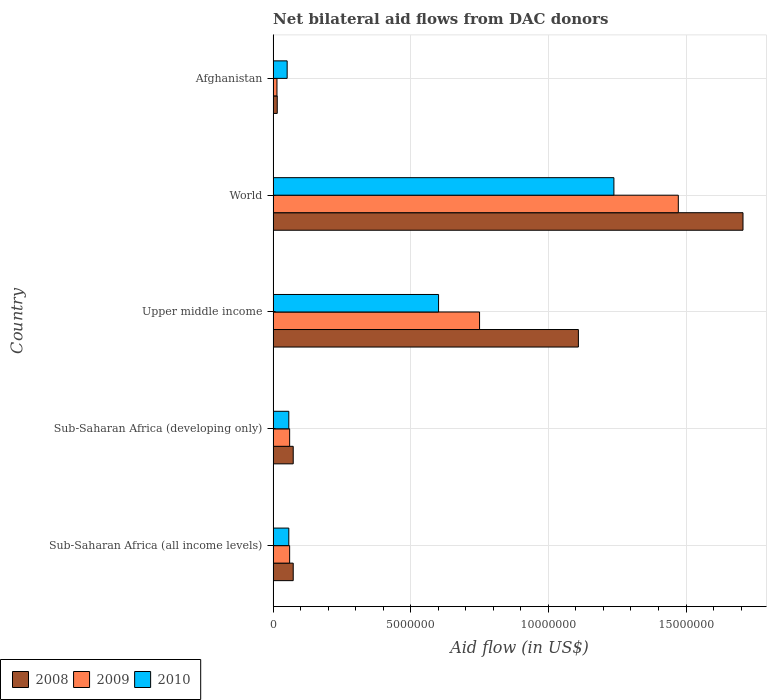How many different coloured bars are there?
Ensure brevity in your answer.  3. How many groups of bars are there?
Your response must be concise. 5. Are the number of bars per tick equal to the number of legend labels?
Offer a terse response. Yes. Are the number of bars on each tick of the Y-axis equal?
Your answer should be very brief. Yes. How many bars are there on the 1st tick from the top?
Provide a succinct answer. 3. How many bars are there on the 5th tick from the bottom?
Provide a short and direct response. 3. In how many cases, is the number of bars for a given country not equal to the number of legend labels?
Give a very brief answer. 0. What is the net bilateral aid flow in 2008 in Upper middle income?
Make the answer very short. 1.11e+07. Across all countries, what is the maximum net bilateral aid flow in 2009?
Provide a succinct answer. 1.47e+07. Across all countries, what is the minimum net bilateral aid flow in 2009?
Your answer should be very brief. 1.40e+05. In which country was the net bilateral aid flow in 2010 maximum?
Provide a succinct answer. World. In which country was the net bilateral aid flow in 2009 minimum?
Keep it short and to the point. Afghanistan. What is the total net bilateral aid flow in 2009 in the graph?
Give a very brief answer. 2.36e+07. What is the difference between the net bilateral aid flow in 2009 in Sub-Saharan Africa (all income levels) and that in World?
Offer a very short reply. -1.41e+07. What is the difference between the net bilateral aid flow in 2009 in Upper middle income and the net bilateral aid flow in 2010 in Afghanistan?
Your answer should be compact. 6.99e+06. What is the average net bilateral aid flow in 2008 per country?
Provide a short and direct response. 5.95e+06. What is the difference between the net bilateral aid flow in 2010 and net bilateral aid flow in 2008 in Sub-Saharan Africa (all income levels)?
Keep it short and to the point. -1.60e+05. In how many countries, is the net bilateral aid flow in 2008 greater than 15000000 US$?
Provide a short and direct response. 1. What is the ratio of the net bilateral aid flow in 2008 in Afghanistan to that in World?
Offer a very short reply. 0.01. What is the difference between the highest and the second highest net bilateral aid flow in 2009?
Ensure brevity in your answer.  7.22e+06. What is the difference between the highest and the lowest net bilateral aid flow in 2010?
Ensure brevity in your answer.  1.19e+07. Is the sum of the net bilateral aid flow in 2010 in Afghanistan and Sub-Saharan Africa (all income levels) greater than the maximum net bilateral aid flow in 2009 across all countries?
Offer a very short reply. No. What does the 3rd bar from the top in Sub-Saharan Africa (all income levels) represents?
Ensure brevity in your answer.  2008. What is the difference between two consecutive major ticks on the X-axis?
Keep it short and to the point. 5.00e+06. Does the graph contain grids?
Give a very brief answer. Yes. Where does the legend appear in the graph?
Provide a short and direct response. Bottom left. How are the legend labels stacked?
Offer a terse response. Horizontal. What is the title of the graph?
Your answer should be very brief. Net bilateral aid flows from DAC donors. What is the label or title of the X-axis?
Offer a very short reply. Aid flow (in US$). What is the label or title of the Y-axis?
Provide a short and direct response. Country. What is the Aid flow (in US$) in 2008 in Sub-Saharan Africa (all income levels)?
Provide a succinct answer. 7.30e+05. What is the Aid flow (in US$) of 2009 in Sub-Saharan Africa (all income levels)?
Your answer should be very brief. 6.00e+05. What is the Aid flow (in US$) of 2010 in Sub-Saharan Africa (all income levels)?
Give a very brief answer. 5.70e+05. What is the Aid flow (in US$) in 2008 in Sub-Saharan Africa (developing only)?
Your answer should be compact. 7.30e+05. What is the Aid flow (in US$) in 2009 in Sub-Saharan Africa (developing only)?
Offer a terse response. 6.00e+05. What is the Aid flow (in US$) in 2010 in Sub-Saharan Africa (developing only)?
Keep it short and to the point. 5.70e+05. What is the Aid flow (in US$) in 2008 in Upper middle income?
Give a very brief answer. 1.11e+07. What is the Aid flow (in US$) in 2009 in Upper middle income?
Your response must be concise. 7.50e+06. What is the Aid flow (in US$) in 2010 in Upper middle income?
Your response must be concise. 6.01e+06. What is the Aid flow (in US$) of 2008 in World?
Offer a very short reply. 1.71e+07. What is the Aid flow (in US$) in 2009 in World?
Ensure brevity in your answer.  1.47e+07. What is the Aid flow (in US$) of 2010 in World?
Keep it short and to the point. 1.24e+07. What is the Aid flow (in US$) in 2010 in Afghanistan?
Your response must be concise. 5.10e+05. Across all countries, what is the maximum Aid flow (in US$) of 2008?
Your answer should be compact. 1.71e+07. Across all countries, what is the maximum Aid flow (in US$) in 2009?
Offer a terse response. 1.47e+07. Across all countries, what is the maximum Aid flow (in US$) of 2010?
Provide a short and direct response. 1.24e+07. Across all countries, what is the minimum Aid flow (in US$) in 2009?
Keep it short and to the point. 1.40e+05. Across all countries, what is the minimum Aid flow (in US$) of 2010?
Provide a short and direct response. 5.10e+05. What is the total Aid flow (in US$) of 2008 in the graph?
Give a very brief answer. 2.98e+07. What is the total Aid flow (in US$) in 2009 in the graph?
Give a very brief answer. 2.36e+07. What is the total Aid flow (in US$) in 2010 in the graph?
Keep it short and to the point. 2.00e+07. What is the difference between the Aid flow (in US$) in 2009 in Sub-Saharan Africa (all income levels) and that in Sub-Saharan Africa (developing only)?
Provide a succinct answer. 0. What is the difference between the Aid flow (in US$) in 2008 in Sub-Saharan Africa (all income levels) and that in Upper middle income?
Offer a very short reply. -1.04e+07. What is the difference between the Aid flow (in US$) in 2009 in Sub-Saharan Africa (all income levels) and that in Upper middle income?
Ensure brevity in your answer.  -6.90e+06. What is the difference between the Aid flow (in US$) of 2010 in Sub-Saharan Africa (all income levels) and that in Upper middle income?
Your answer should be very brief. -5.44e+06. What is the difference between the Aid flow (in US$) of 2008 in Sub-Saharan Africa (all income levels) and that in World?
Keep it short and to the point. -1.63e+07. What is the difference between the Aid flow (in US$) of 2009 in Sub-Saharan Africa (all income levels) and that in World?
Provide a short and direct response. -1.41e+07. What is the difference between the Aid flow (in US$) of 2010 in Sub-Saharan Africa (all income levels) and that in World?
Your answer should be compact. -1.18e+07. What is the difference between the Aid flow (in US$) in 2008 in Sub-Saharan Africa (all income levels) and that in Afghanistan?
Provide a succinct answer. 5.80e+05. What is the difference between the Aid flow (in US$) of 2009 in Sub-Saharan Africa (all income levels) and that in Afghanistan?
Provide a succinct answer. 4.60e+05. What is the difference between the Aid flow (in US$) in 2010 in Sub-Saharan Africa (all income levels) and that in Afghanistan?
Ensure brevity in your answer.  6.00e+04. What is the difference between the Aid flow (in US$) of 2008 in Sub-Saharan Africa (developing only) and that in Upper middle income?
Keep it short and to the point. -1.04e+07. What is the difference between the Aid flow (in US$) of 2009 in Sub-Saharan Africa (developing only) and that in Upper middle income?
Ensure brevity in your answer.  -6.90e+06. What is the difference between the Aid flow (in US$) of 2010 in Sub-Saharan Africa (developing only) and that in Upper middle income?
Your response must be concise. -5.44e+06. What is the difference between the Aid flow (in US$) in 2008 in Sub-Saharan Africa (developing only) and that in World?
Your answer should be compact. -1.63e+07. What is the difference between the Aid flow (in US$) in 2009 in Sub-Saharan Africa (developing only) and that in World?
Offer a very short reply. -1.41e+07. What is the difference between the Aid flow (in US$) of 2010 in Sub-Saharan Africa (developing only) and that in World?
Your answer should be very brief. -1.18e+07. What is the difference between the Aid flow (in US$) of 2008 in Sub-Saharan Africa (developing only) and that in Afghanistan?
Make the answer very short. 5.80e+05. What is the difference between the Aid flow (in US$) in 2009 in Sub-Saharan Africa (developing only) and that in Afghanistan?
Your response must be concise. 4.60e+05. What is the difference between the Aid flow (in US$) of 2010 in Sub-Saharan Africa (developing only) and that in Afghanistan?
Your answer should be very brief. 6.00e+04. What is the difference between the Aid flow (in US$) in 2008 in Upper middle income and that in World?
Offer a terse response. -5.98e+06. What is the difference between the Aid flow (in US$) of 2009 in Upper middle income and that in World?
Offer a terse response. -7.22e+06. What is the difference between the Aid flow (in US$) of 2010 in Upper middle income and that in World?
Provide a short and direct response. -6.37e+06. What is the difference between the Aid flow (in US$) of 2008 in Upper middle income and that in Afghanistan?
Your answer should be very brief. 1.09e+07. What is the difference between the Aid flow (in US$) of 2009 in Upper middle income and that in Afghanistan?
Ensure brevity in your answer.  7.36e+06. What is the difference between the Aid flow (in US$) in 2010 in Upper middle income and that in Afghanistan?
Your answer should be compact. 5.50e+06. What is the difference between the Aid flow (in US$) of 2008 in World and that in Afghanistan?
Provide a succinct answer. 1.69e+07. What is the difference between the Aid flow (in US$) of 2009 in World and that in Afghanistan?
Give a very brief answer. 1.46e+07. What is the difference between the Aid flow (in US$) of 2010 in World and that in Afghanistan?
Give a very brief answer. 1.19e+07. What is the difference between the Aid flow (in US$) in 2008 in Sub-Saharan Africa (all income levels) and the Aid flow (in US$) in 2009 in Sub-Saharan Africa (developing only)?
Your answer should be compact. 1.30e+05. What is the difference between the Aid flow (in US$) in 2008 in Sub-Saharan Africa (all income levels) and the Aid flow (in US$) in 2009 in Upper middle income?
Make the answer very short. -6.77e+06. What is the difference between the Aid flow (in US$) of 2008 in Sub-Saharan Africa (all income levels) and the Aid flow (in US$) of 2010 in Upper middle income?
Your response must be concise. -5.28e+06. What is the difference between the Aid flow (in US$) in 2009 in Sub-Saharan Africa (all income levels) and the Aid flow (in US$) in 2010 in Upper middle income?
Your response must be concise. -5.41e+06. What is the difference between the Aid flow (in US$) of 2008 in Sub-Saharan Africa (all income levels) and the Aid flow (in US$) of 2009 in World?
Provide a succinct answer. -1.40e+07. What is the difference between the Aid flow (in US$) of 2008 in Sub-Saharan Africa (all income levels) and the Aid flow (in US$) of 2010 in World?
Keep it short and to the point. -1.16e+07. What is the difference between the Aid flow (in US$) of 2009 in Sub-Saharan Africa (all income levels) and the Aid flow (in US$) of 2010 in World?
Offer a terse response. -1.18e+07. What is the difference between the Aid flow (in US$) in 2008 in Sub-Saharan Africa (all income levels) and the Aid flow (in US$) in 2009 in Afghanistan?
Your answer should be very brief. 5.90e+05. What is the difference between the Aid flow (in US$) in 2008 in Sub-Saharan Africa (all income levels) and the Aid flow (in US$) in 2010 in Afghanistan?
Make the answer very short. 2.20e+05. What is the difference between the Aid flow (in US$) in 2008 in Sub-Saharan Africa (developing only) and the Aid flow (in US$) in 2009 in Upper middle income?
Your response must be concise. -6.77e+06. What is the difference between the Aid flow (in US$) of 2008 in Sub-Saharan Africa (developing only) and the Aid flow (in US$) of 2010 in Upper middle income?
Give a very brief answer. -5.28e+06. What is the difference between the Aid flow (in US$) of 2009 in Sub-Saharan Africa (developing only) and the Aid flow (in US$) of 2010 in Upper middle income?
Offer a very short reply. -5.41e+06. What is the difference between the Aid flow (in US$) of 2008 in Sub-Saharan Africa (developing only) and the Aid flow (in US$) of 2009 in World?
Make the answer very short. -1.40e+07. What is the difference between the Aid flow (in US$) of 2008 in Sub-Saharan Africa (developing only) and the Aid flow (in US$) of 2010 in World?
Your response must be concise. -1.16e+07. What is the difference between the Aid flow (in US$) in 2009 in Sub-Saharan Africa (developing only) and the Aid flow (in US$) in 2010 in World?
Your answer should be compact. -1.18e+07. What is the difference between the Aid flow (in US$) of 2008 in Sub-Saharan Africa (developing only) and the Aid flow (in US$) of 2009 in Afghanistan?
Offer a very short reply. 5.90e+05. What is the difference between the Aid flow (in US$) of 2008 in Upper middle income and the Aid flow (in US$) of 2009 in World?
Offer a terse response. -3.63e+06. What is the difference between the Aid flow (in US$) of 2008 in Upper middle income and the Aid flow (in US$) of 2010 in World?
Your response must be concise. -1.29e+06. What is the difference between the Aid flow (in US$) of 2009 in Upper middle income and the Aid flow (in US$) of 2010 in World?
Keep it short and to the point. -4.88e+06. What is the difference between the Aid flow (in US$) of 2008 in Upper middle income and the Aid flow (in US$) of 2009 in Afghanistan?
Give a very brief answer. 1.10e+07. What is the difference between the Aid flow (in US$) of 2008 in Upper middle income and the Aid flow (in US$) of 2010 in Afghanistan?
Offer a terse response. 1.06e+07. What is the difference between the Aid flow (in US$) of 2009 in Upper middle income and the Aid flow (in US$) of 2010 in Afghanistan?
Your answer should be very brief. 6.99e+06. What is the difference between the Aid flow (in US$) in 2008 in World and the Aid flow (in US$) in 2009 in Afghanistan?
Your response must be concise. 1.69e+07. What is the difference between the Aid flow (in US$) of 2008 in World and the Aid flow (in US$) of 2010 in Afghanistan?
Provide a short and direct response. 1.66e+07. What is the difference between the Aid flow (in US$) of 2009 in World and the Aid flow (in US$) of 2010 in Afghanistan?
Give a very brief answer. 1.42e+07. What is the average Aid flow (in US$) in 2008 per country?
Give a very brief answer. 5.95e+06. What is the average Aid flow (in US$) of 2009 per country?
Ensure brevity in your answer.  4.71e+06. What is the average Aid flow (in US$) of 2010 per country?
Keep it short and to the point. 4.01e+06. What is the difference between the Aid flow (in US$) in 2009 and Aid flow (in US$) in 2010 in Sub-Saharan Africa (all income levels)?
Offer a terse response. 3.00e+04. What is the difference between the Aid flow (in US$) of 2008 and Aid flow (in US$) of 2009 in Sub-Saharan Africa (developing only)?
Ensure brevity in your answer.  1.30e+05. What is the difference between the Aid flow (in US$) of 2008 and Aid flow (in US$) of 2010 in Sub-Saharan Africa (developing only)?
Your answer should be compact. 1.60e+05. What is the difference between the Aid flow (in US$) of 2009 and Aid flow (in US$) of 2010 in Sub-Saharan Africa (developing only)?
Offer a very short reply. 3.00e+04. What is the difference between the Aid flow (in US$) in 2008 and Aid flow (in US$) in 2009 in Upper middle income?
Give a very brief answer. 3.59e+06. What is the difference between the Aid flow (in US$) in 2008 and Aid flow (in US$) in 2010 in Upper middle income?
Your answer should be compact. 5.08e+06. What is the difference between the Aid flow (in US$) of 2009 and Aid flow (in US$) of 2010 in Upper middle income?
Make the answer very short. 1.49e+06. What is the difference between the Aid flow (in US$) of 2008 and Aid flow (in US$) of 2009 in World?
Give a very brief answer. 2.35e+06. What is the difference between the Aid flow (in US$) in 2008 and Aid flow (in US$) in 2010 in World?
Give a very brief answer. 4.69e+06. What is the difference between the Aid flow (in US$) of 2009 and Aid flow (in US$) of 2010 in World?
Your answer should be very brief. 2.34e+06. What is the difference between the Aid flow (in US$) in 2008 and Aid flow (in US$) in 2009 in Afghanistan?
Offer a very short reply. 10000. What is the difference between the Aid flow (in US$) in 2008 and Aid flow (in US$) in 2010 in Afghanistan?
Offer a terse response. -3.60e+05. What is the difference between the Aid flow (in US$) of 2009 and Aid flow (in US$) of 2010 in Afghanistan?
Your answer should be very brief. -3.70e+05. What is the ratio of the Aid flow (in US$) in 2008 in Sub-Saharan Africa (all income levels) to that in Sub-Saharan Africa (developing only)?
Offer a very short reply. 1. What is the ratio of the Aid flow (in US$) in 2008 in Sub-Saharan Africa (all income levels) to that in Upper middle income?
Keep it short and to the point. 0.07. What is the ratio of the Aid flow (in US$) of 2010 in Sub-Saharan Africa (all income levels) to that in Upper middle income?
Make the answer very short. 0.09. What is the ratio of the Aid flow (in US$) in 2008 in Sub-Saharan Africa (all income levels) to that in World?
Offer a very short reply. 0.04. What is the ratio of the Aid flow (in US$) in 2009 in Sub-Saharan Africa (all income levels) to that in World?
Give a very brief answer. 0.04. What is the ratio of the Aid flow (in US$) of 2010 in Sub-Saharan Africa (all income levels) to that in World?
Provide a succinct answer. 0.05. What is the ratio of the Aid flow (in US$) in 2008 in Sub-Saharan Africa (all income levels) to that in Afghanistan?
Make the answer very short. 4.87. What is the ratio of the Aid flow (in US$) in 2009 in Sub-Saharan Africa (all income levels) to that in Afghanistan?
Your answer should be compact. 4.29. What is the ratio of the Aid flow (in US$) in 2010 in Sub-Saharan Africa (all income levels) to that in Afghanistan?
Give a very brief answer. 1.12. What is the ratio of the Aid flow (in US$) in 2008 in Sub-Saharan Africa (developing only) to that in Upper middle income?
Keep it short and to the point. 0.07. What is the ratio of the Aid flow (in US$) in 2009 in Sub-Saharan Africa (developing only) to that in Upper middle income?
Provide a short and direct response. 0.08. What is the ratio of the Aid flow (in US$) of 2010 in Sub-Saharan Africa (developing only) to that in Upper middle income?
Your answer should be compact. 0.09. What is the ratio of the Aid flow (in US$) in 2008 in Sub-Saharan Africa (developing only) to that in World?
Keep it short and to the point. 0.04. What is the ratio of the Aid flow (in US$) in 2009 in Sub-Saharan Africa (developing only) to that in World?
Keep it short and to the point. 0.04. What is the ratio of the Aid flow (in US$) in 2010 in Sub-Saharan Africa (developing only) to that in World?
Provide a short and direct response. 0.05. What is the ratio of the Aid flow (in US$) of 2008 in Sub-Saharan Africa (developing only) to that in Afghanistan?
Your answer should be very brief. 4.87. What is the ratio of the Aid flow (in US$) in 2009 in Sub-Saharan Africa (developing only) to that in Afghanistan?
Make the answer very short. 4.29. What is the ratio of the Aid flow (in US$) in 2010 in Sub-Saharan Africa (developing only) to that in Afghanistan?
Your response must be concise. 1.12. What is the ratio of the Aid flow (in US$) of 2008 in Upper middle income to that in World?
Keep it short and to the point. 0.65. What is the ratio of the Aid flow (in US$) of 2009 in Upper middle income to that in World?
Your answer should be very brief. 0.51. What is the ratio of the Aid flow (in US$) of 2010 in Upper middle income to that in World?
Provide a succinct answer. 0.49. What is the ratio of the Aid flow (in US$) in 2008 in Upper middle income to that in Afghanistan?
Keep it short and to the point. 73.93. What is the ratio of the Aid flow (in US$) in 2009 in Upper middle income to that in Afghanistan?
Offer a very short reply. 53.57. What is the ratio of the Aid flow (in US$) in 2010 in Upper middle income to that in Afghanistan?
Your answer should be compact. 11.78. What is the ratio of the Aid flow (in US$) of 2008 in World to that in Afghanistan?
Your answer should be very brief. 113.8. What is the ratio of the Aid flow (in US$) of 2009 in World to that in Afghanistan?
Offer a terse response. 105.14. What is the ratio of the Aid flow (in US$) of 2010 in World to that in Afghanistan?
Offer a very short reply. 24.27. What is the difference between the highest and the second highest Aid flow (in US$) in 2008?
Offer a very short reply. 5.98e+06. What is the difference between the highest and the second highest Aid flow (in US$) of 2009?
Offer a very short reply. 7.22e+06. What is the difference between the highest and the second highest Aid flow (in US$) in 2010?
Keep it short and to the point. 6.37e+06. What is the difference between the highest and the lowest Aid flow (in US$) in 2008?
Offer a very short reply. 1.69e+07. What is the difference between the highest and the lowest Aid flow (in US$) in 2009?
Give a very brief answer. 1.46e+07. What is the difference between the highest and the lowest Aid flow (in US$) in 2010?
Give a very brief answer. 1.19e+07. 